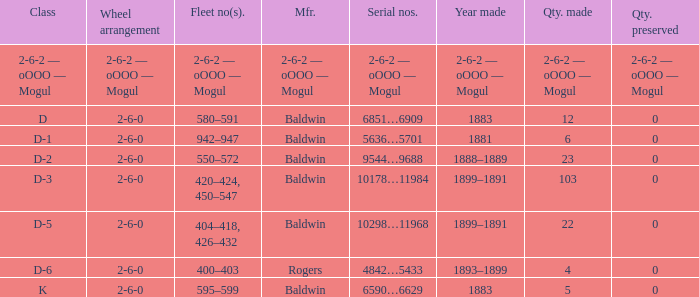What is the quantity made when the wheel arrangement is 2-6-0 and the class is k? 5.0. 